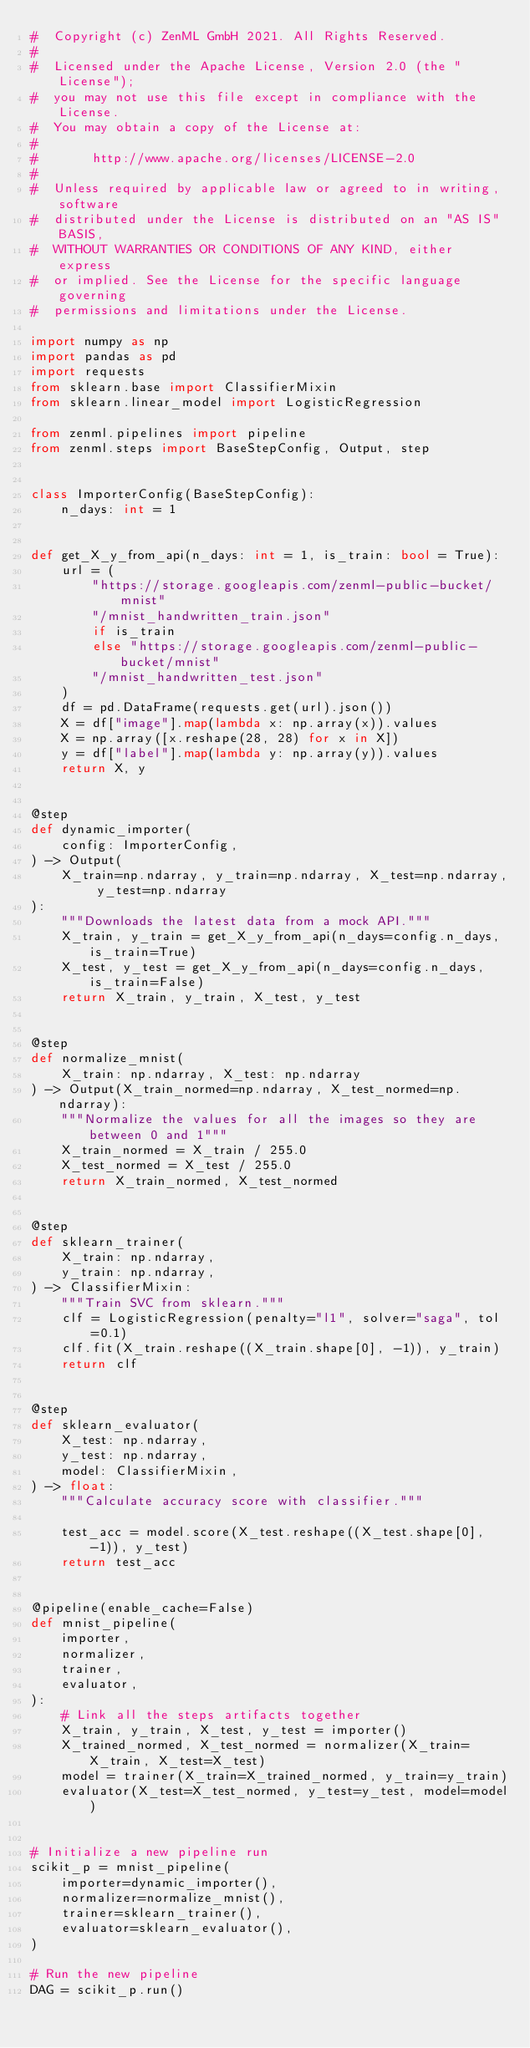<code> <loc_0><loc_0><loc_500><loc_500><_Python_>#  Copyright (c) ZenML GmbH 2021. All Rights Reserved.
#
#  Licensed under the Apache License, Version 2.0 (the "License");
#  you may not use this file except in compliance with the License.
#  You may obtain a copy of the License at:
#
#       http://www.apache.org/licenses/LICENSE-2.0
#
#  Unless required by applicable law or agreed to in writing, software
#  distributed under the License is distributed on an "AS IS" BASIS,
#  WITHOUT WARRANTIES OR CONDITIONS OF ANY KIND, either express
#  or implied. See the License for the specific language governing
#  permissions and limitations under the License.

import numpy as np
import pandas as pd
import requests
from sklearn.base import ClassifierMixin
from sklearn.linear_model import LogisticRegression

from zenml.pipelines import pipeline
from zenml.steps import BaseStepConfig, Output, step


class ImporterConfig(BaseStepConfig):
    n_days: int = 1


def get_X_y_from_api(n_days: int = 1, is_train: bool = True):
    url = (
        "https://storage.googleapis.com/zenml-public-bucket/mnist"
        "/mnist_handwritten_train.json"
        if is_train
        else "https://storage.googleapis.com/zenml-public-bucket/mnist"
        "/mnist_handwritten_test.json"
    )
    df = pd.DataFrame(requests.get(url).json())
    X = df["image"].map(lambda x: np.array(x)).values
    X = np.array([x.reshape(28, 28) for x in X])
    y = df["label"].map(lambda y: np.array(y)).values
    return X, y


@step
def dynamic_importer(
    config: ImporterConfig,
) -> Output(
    X_train=np.ndarray, y_train=np.ndarray, X_test=np.ndarray, y_test=np.ndarray
):
    """Downloads the latest data from a mock API."""
    X_train, y_train = get_X_y_from_api(n_days=config.n_days, is_train=True)
    X_test, y_test = get_X_y_from_api(n_days=config.n_days, is_train=False)
    return X_train, y_train, X_test, y_test


@step
def normalize_mnist(
    X_train: np.ndarray, X_test: np.ndarray
) -> Output(X_train_normed=np.ndarray, X_test_normed=np.ndarray):
    """Normalize the values for all the images so they are between 0 and 1"""
    X_train_normed = X_train / 255.0
    X_test_normed = X_test / 255.0
    return X_train_normed, X_test_normed


@step
def sklearn_trainer(
    X_train: np.ndarray,
    y_train: np.ndarray,
) -> ClassifierMixin:
    """Train SVC from sklearn."""
    clf = LogisticRegression(penalty="l1", solver="saga", tol=0.1)
    clf.fit(X_train.reshape((X_train.shape[0], -1)), y_train)
    return clf


@step
def sklearn_evaluator(
    X_test: np.ndarray,
    y_test: np.ndarray,
    model: ClassifierMixin,
) -> float:
    """Calculate accuracy score with classifier."""

    test_acc = model.score(X_test.reshape((X_test.shape[0], -1)), y_test)
    return test_acc


@pipeline(enable_cache=False)
def mnist_pipeline(
    importer,
    normalizer,
    trainer,
    evaluator,
):
    # Link all the steps artifacts together
    X_train, y_train, X_test, y_test = importer()
    X_trained_normed, X_test_normed = normalizer(X_train=X_train, X_test=X_test)
    model = trainer(X_train=X_trained_normed, y_train=y_train)
    evaluator(X_test=X_test_normed, y_test=y_test, model=model)


# Initialize a new pipeline run
scikit_p = mnist_pipeline(
    importer=dynamic_importer(),
    normalizer=normalize_mnist(),
    trainer=sklearn_trainer(),
    evaluator=sklearn_evaluator(),
)

# Run the new pipeline
DAG = scikit_p.run()
</code> 